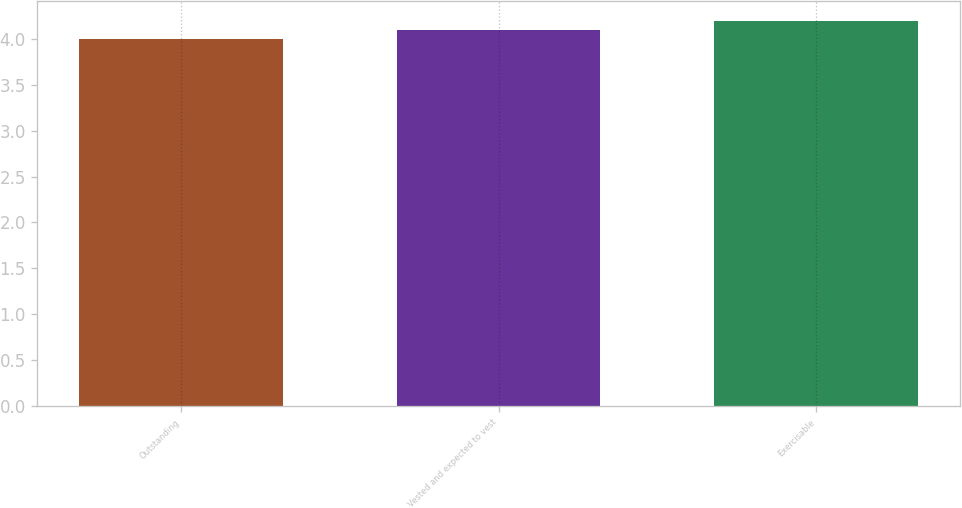<chart> <loc_0><loc_0><loc_500><loc_500><bar_chart><fcel>Outstanding<fcel>Vested and expected to vest<fcel>Exercisable<nl><fcel>4<fcel>4.1<fcel>4.2<nl></chart> 